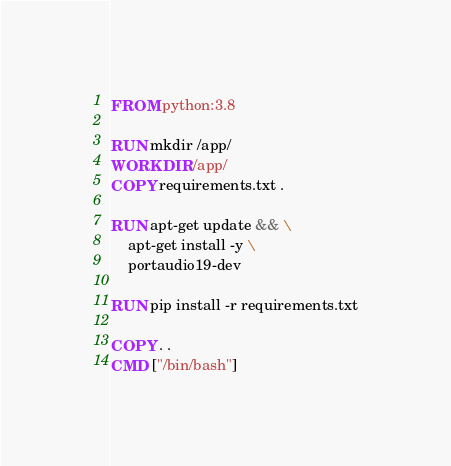Convert code to text. <code><loc_0><loc_0><loc_500><loc_500><_Dockerfile_>FROM python:3.8

RUN mkdir /app/
WORKDIR /app/
COPY requirements.txt .

RUN apt-get update && \
    apt-get install -y \
    portaudio19-dev

RUN pip install -r requirements.txt

COPY . .
CMD ["/bin/bash"]</code> 